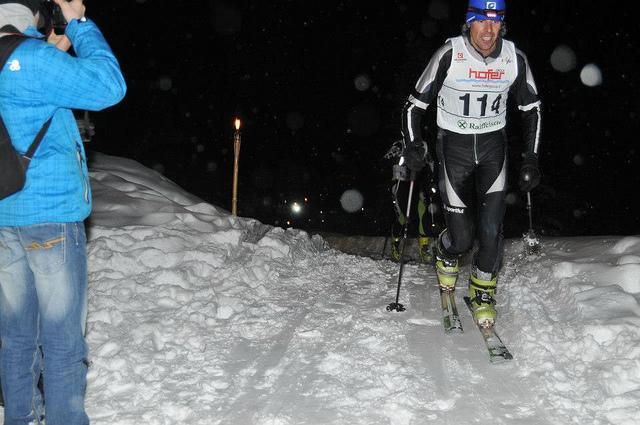What is that light in the distance called?
Pick the right solution, then justify: 'Answer: answer
Rationale: rationale.'
Options: Lamp, post, street lamp, torch. Answer: torch.
Rationale: The light is a torch. 